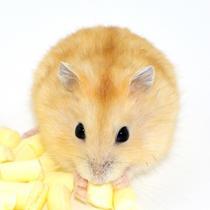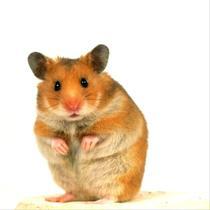The first image is the image on the left, the second image is the image on the right. Considering the images on both sides, is "There are exactly two hamsters in total." valid? Answer yes or no. Yes. 